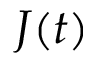Convert formula to latex. <formula><loc_0><loc_0><loc_500><loc_500>J ( t )</formula> 